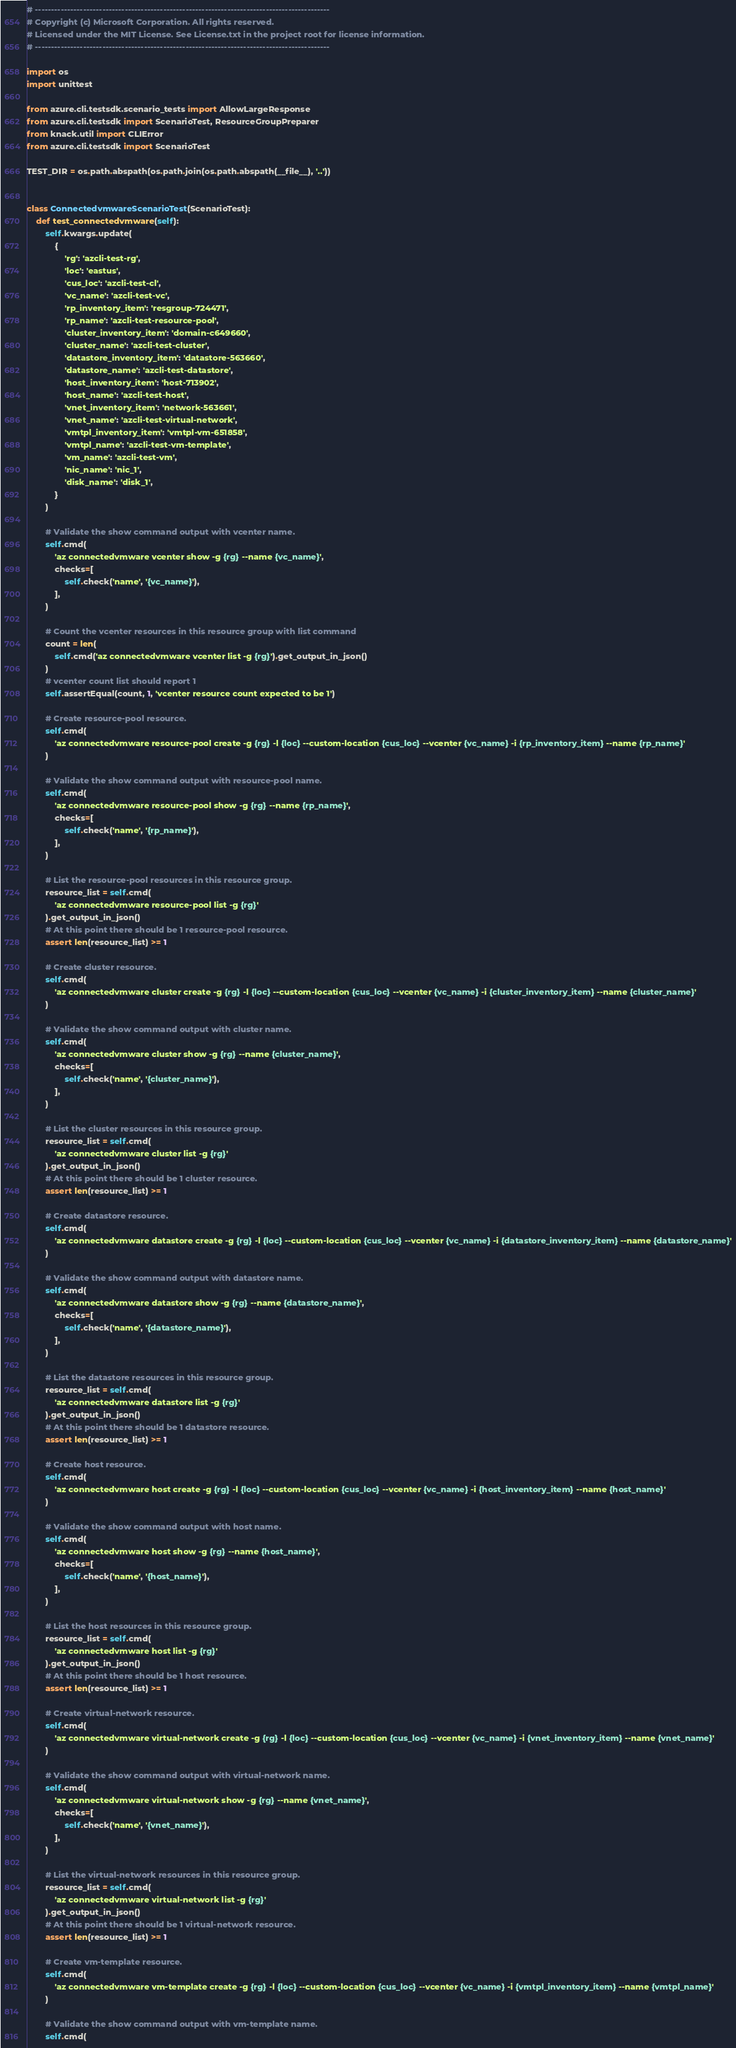Convert code to text. <code><loc_0><loc_0><loc_500><loc_500><_Python_># --------------------------------------------------------------------------------------------
# Copyright (c) Microsoft Corporation. All rights reserved.
# Licensed under the MIT License. See License.txt in the project root for license information.
# --------------------------------------------------------------------------------------------

import os
import unittest

from azure.cli.testsdk.scenario_tests import AllowLargeResponse
from azure.cli.testsdk import ScenarioTest, ResourceGroupPreparer
from knack.util import CLIError
from azure.cli.testsdk import ScenarioTest

TEST_DIR = os.path.abspath(os.path.join(os.path.abspath(__file__), '..'))


class ConnectedvmwareScenarioTest(ScenarioTest):
    def test_connectedvmware(self):
        self.kwargs.update(
            {
                'rg': 'azcli-test-rg',
                'loc': 'eastus',
                'cus_loc': 'azcli-test-cl',
                'vc_name': 'azcli-test-vc',
                'rp_inventory_item': 'resgroup-724471',
                'rp_name': 'azcli-test-resource-pool',
                'cluster_inventory_item': 'domain-c649660',
                'cluster_name': 'azcli-test-cluster',
                'datastore_inventory_item': 'datastore-563660',
                'datastore_name': 'azcli-test-datastore',
                'host_inventory_item': 'host-713902',
                'host_name': 'azcli-test-host',
                'vnet_inventory_item': 'network-563661',
                'vnet_name': 'azcli-test-virtual-network',
                'vmtpl_inventory_item': 'vmtpl-vm-651858',
                'vmtpl_name': 'azcli-test-vm-template',
                'vm_name': 'azcli-test-vm',
                'nic_name': 'nic_1',
                'disk_name': 'disk_1',
            }
        )

        # Validate the show command output with vcenter name.
        self.cmd(
            'az connectedvmware vcenter show -g {rg} --name {vc_name}',
            checks=[
                self.check('name', '{vc_name}'),
            ],
        )

        # Count the vcenter resources in this resource group with list command
        count = len(
            self.cmd('az connectedvmware vcenter list -g {rg}').get_output_in_json()
        )
        # vcenter count list should report 1
        self.assertEqual(count, 1, 'vcenter resource count expected to be 1')

        # Create resource-pool resource.
        self.cmd(
            'az connectedvmware resource-pool create -g {rg} -l {loc} --custom-location {cus_loc} --vcenter {vc_name} -i {rp_inventory_item} --name {rp_name}'
        )

        # Validate the show command output with resource-pool name.
        self.cmd(
            'az connectedvmware resource-pool show -g {rg} --name {rp_name}',
            checks=[
                self.check('name', '{rp_name}'),
            ],
        )

        # List the resource-pool resources in this resource group.
        resource_list = self.cmd(
            'az connectedvmware resource-pool list -g {rg}'
        ).get_output_in_json()
        # At this point there should be 1 resource-pool resource.
        assert len(resource_list) >= 1

        # Create cluster resource.
        self.cmd(
            'az connectedvmware cluster create -g {rg} -l {loc} --custom-location {cus_loc} --vcenter {vc_name} -i {cluster_inventory_item} --name {cluster_name}'
        )

        # Validate the show command output with cluster name.
        self.cmd(
            'az connectedvmware cluster show -g {rg} --name {cluster_name}',
            checks=[
                self.check('name', '{cluster_name}'),
            ],
        )

        # List the cluster resources in this resource group.
        resource_list = self.cmd(
            'az connectedvmware cluster list -g {rg}'
        ).get_output_in_json()
        # At this point there should be 1 cluster resource.
        assert len(resource_list) >= 1

        # Create datastore resource.
        self.cmd(
            'az connectedvmware datastore create -g {rg} -l {loc} --custom-location {cus_loc} --vcenter {vc_name} -i {datastore_inventory_item} --name {datastore_name}'
        )

        # Validate the show command output with datastore name.
        self.cmd(
            'az connectedvmware datastore show -g {rg} --name {datastore_name}',
            checks=[
                self.check('name', '{datastore_name}'),
            ],
        )

        # List the datastore resources in this resource group.
        resource_list = self.cmd(
            'az connectedvmware datastore list -g {rg}'
        ).get_output_in_json()
        # At this point there should be 1 datastore resource.
        assert len(resource_list) >= 1

        # Create host resource.
        self.cmd(
            'az connectedvmware host create -g {rg} -l {loc} --custom-location {cus_loc} --vcenter {vc_name} -i {host_inventory_item} --name {host_name}'
        )

        # Validate the show command output with host name.
        self.cmd(
            'az connectedvmware host show -g {rg} --name {host_name}',
            checks=[
                self.check('name', '{host_name}'),
            ],
        )

        # List the host resources in this resource group.
        resource_list = self.cmd(
            'az connectedvmware host list -g {rg}'
        ).get_output_in_json()
        # At this point there should be 1 host resource.
        assert len(resource_list) >= 1

        # Create virtual-network resource.
        self.cmd(
            'az connectedvmware virtual-network create -g {rg} -l {loc} --custom-location {cus_loc} --vcenter {vc_name} -i {vnet_inventory_item} --name {vnet_name}'
        )

        # Validate the show command output with virtual-network name.
        self.cmd(
            'az connectedvmware virtual-network show -g {rg} --name {vnet_name}',
            checks=[
                self.check('name', '{vnet_name}'),
            ],
        )

        # List the virtual-network resources in this resource group.
        resource_list = self.cmd(
            'az connectedvmware virtual-network list -g {rg}'
        ).get_output_in_json()
        # At this point there should be 1 virtual-network resource.
        assert len(resource_list) >= 1

        # Create vm-template resource.
        self.cmd(
            'az connectedvmware vm-template create -g {rg} -l {loc} --custom-location {cus_loc} --vcenter {vc_name} -i {vmtpl_inventory_item} --name {vmtpl_name}'
        )

        # Validate the show command output with vm-template name.
        self.cmd(</code> 